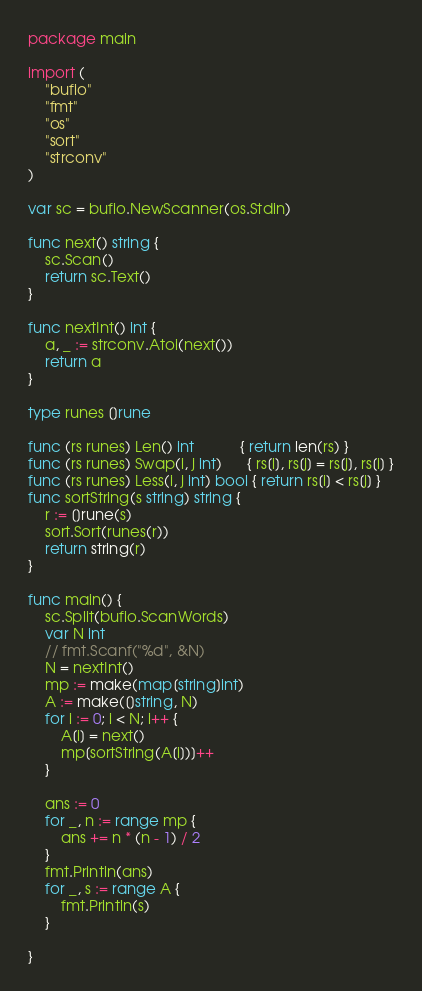<code> <loc_0><loc_0><loc_500><loc_500><_Go_>package main

import (
	"bufio"
	"fmt"
	"os"
	"sort"
	"strconv"
)

var sc = bufio.NewScanner(os.Stdin)

func next() string {
	sc.Scan()
	return sc.Text()
}

func nextInt() int {
	a, _ := strconv.Atoi(next())
	return a
}

type runes []rune

func (rs runes) Len() int           { return len(rs) }
func (rs runes) Swap(i, j int)      { rs[i], rs[j] = rs[j], rs[i] }
func (rs runes) Less(i, j int) bool { return rs[i] < rs[j] }
func sortString(s string) string {
	r := []rune(s)
	sort.Sort(runes(r))
	return string(r)
}

func main() {
	sc.Split(bufio.ScanWords)
	var N int
	// fmt.Scanf("%d", &N)
	N = nextInt()
	mp := make(map[string]int)
	A := make([]string, N)
	for i := 0; i < N; i++ {
		A[i] = next()
		mp[sortString(A[i])]++
	}

	ans := 0
	for _, n := range mp {
		ans += n * (n - 1) / 2
	}
	fmt.Println(ans)
	for _, s := range A {
		fmt.Println(s)
	}

}
</code> 